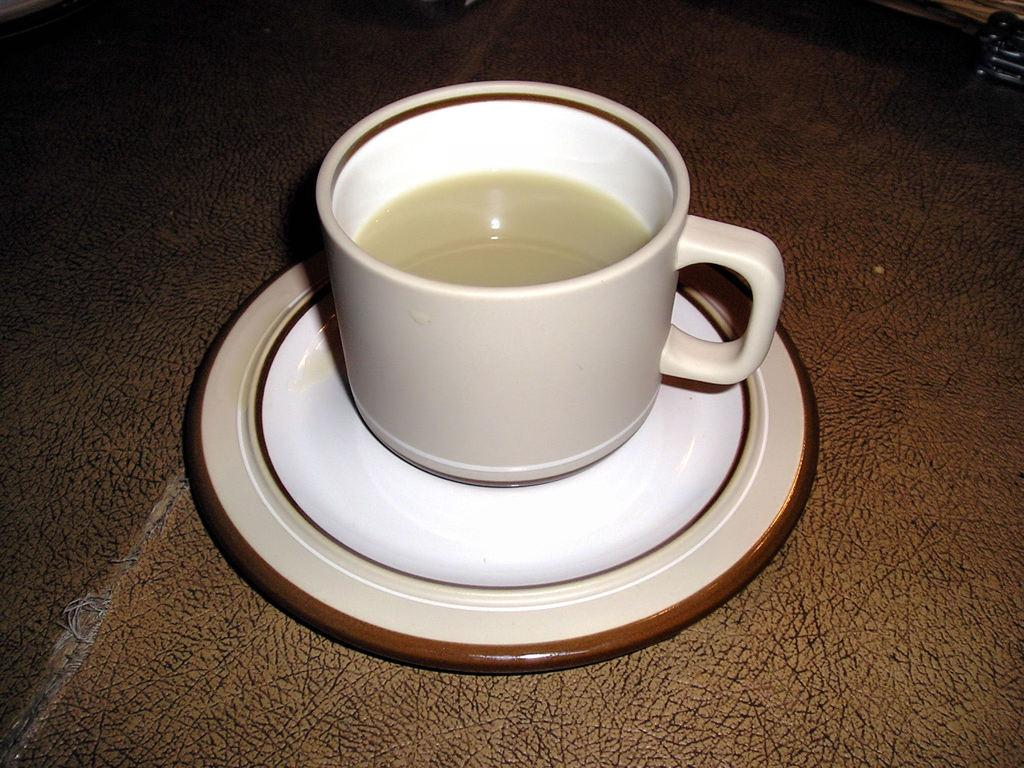What is in the cup that is visible in the image? There is a cup in the image, and it contains coffee. What accompanies the cup in the image? There is a saucer in the image. What is the color of the coffee in the cup? The coffee is cream in color. What is the color of the saucer's border? The saucer has a brown border. What type of flower is depicted on the saucer in the image? There is no flower depicted on the saucer in the image; it only has a brown border. What thought or emotion can be seen on the face of the coffee in the image? There is no face or emotion depicted in the image; it only features a cup, coffee, a saucer, and a brown border. 